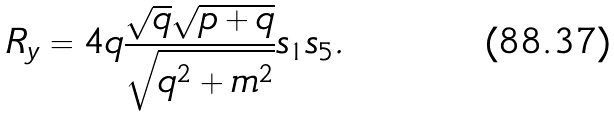<formula> <loc_0><loc_0><loc_500><loc_500>R _ { y } = 4 q \frac { \sqrt { q } \sqrt { p + q } } { \sqrt { q ^ { 2 } + m ^ { 2 } } } s _ { 1 } s _ { 5 } .</formula> 